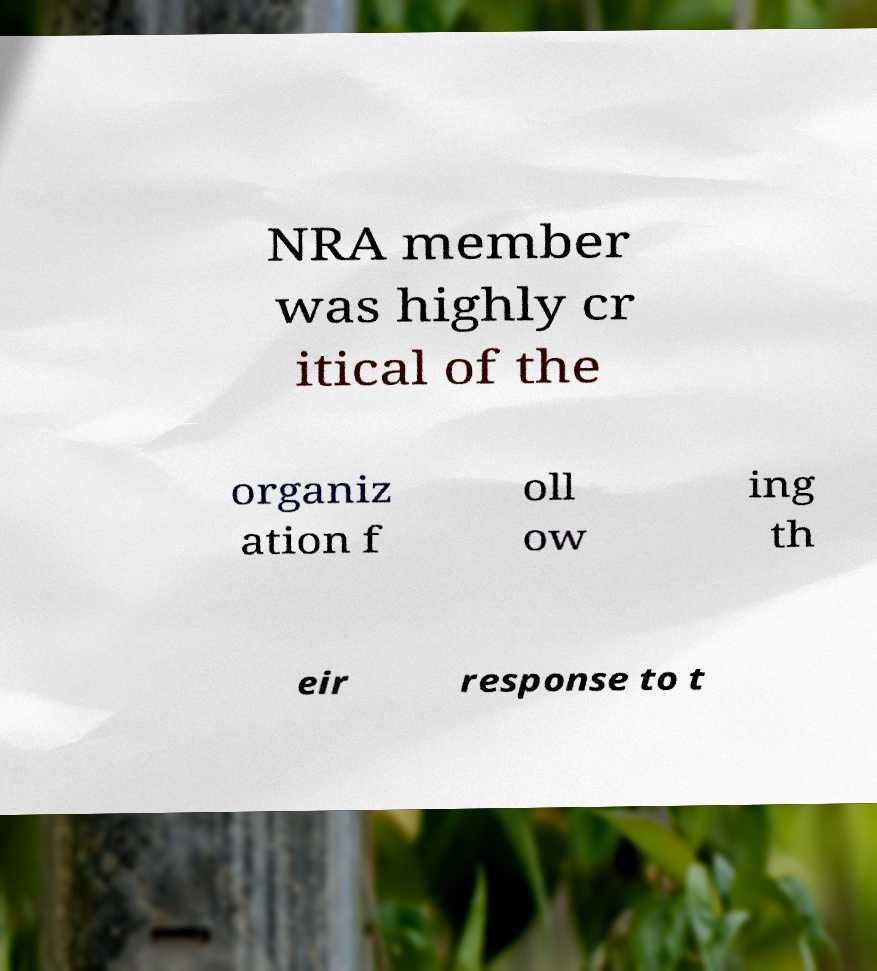Can you accurately transcribe the text from the provided image for me? NRA member was highly cr itical of the organiz ation f oll ow ing th eir response to t 